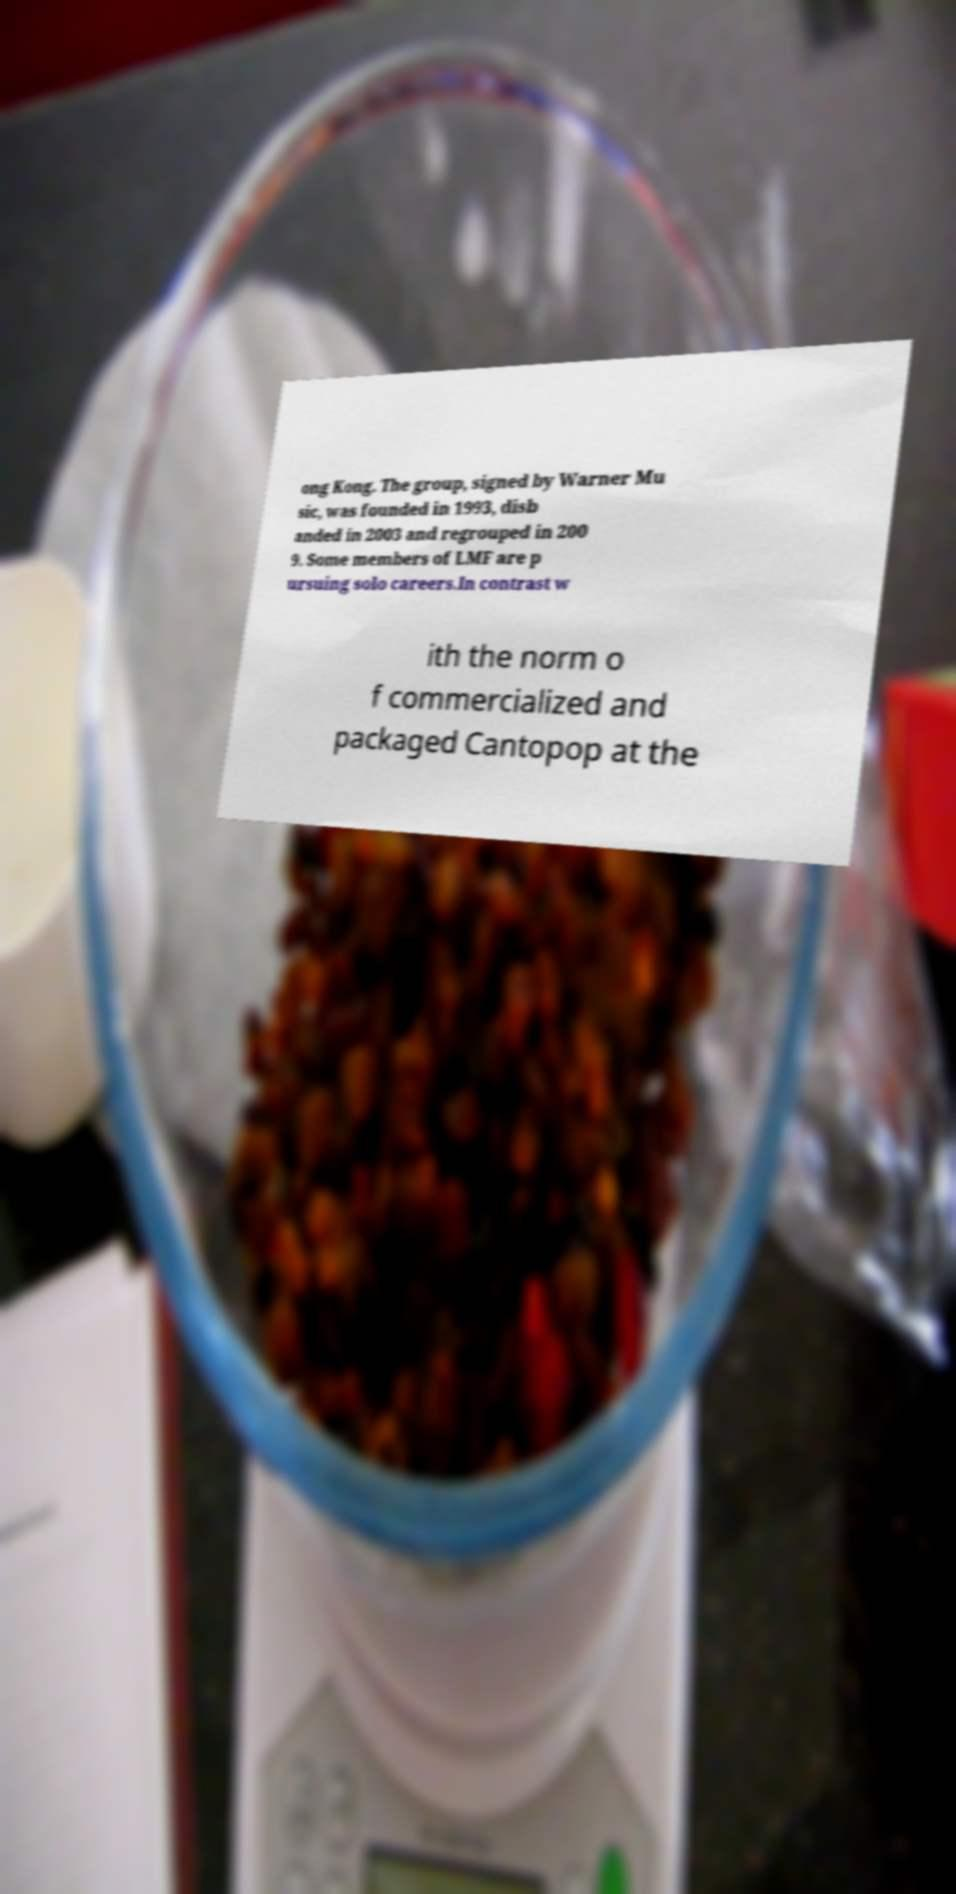There's text embedded in this image that I need extracted. Can you transcribe it verbatim? ong Kong. The group, signed by Warner Mu sic, was founded in 1993, disb anded in 2003 and regrouped in 200 9. Some members of LMF are p ursuing solo careers.In contrast w ith the norm o f commercialized and packaged Cantopop at the 